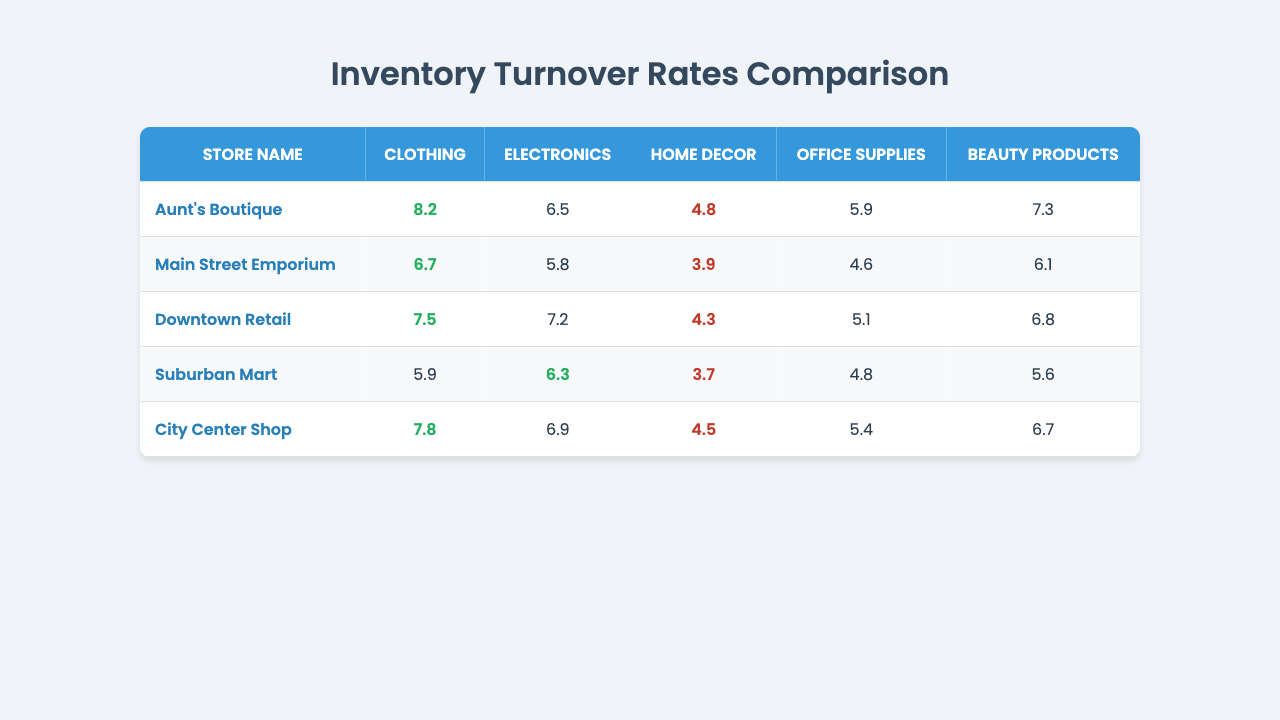What is the highest inventory turnover rate for beauty products? Looking at the beauty products column, Aunt's Boutique has the highest turnover rate at 7.3.
Answer: 7.3 Which store has the lowest turnover rate for home decor? In the home decor column, Suburban Mart has the lowest rate of 3.7.
Answer: 3.7 What is the average inventory turnover rate for clothing across all stores? The turnover rates for clothing are 8.2, 6.7, 7.5, 5.9, and 7.8. Summing these gives 35.1, and dividing by 5 results in an average of 7.02.
Answer: 7.02 Is it true that Downtown Retail has a higher turnover rate for electronics than Aunt's Boutique? Aunt's Boutique has a turnover rate of 6.5 for electronics, while Downtown Retail has 7.2. Since 7.2 is greater than 6.5, the statement is true.
Answer: True Which store has the best overall performance on inventory turnover rates, and why? Aunt's Boutique has the highest turnover rates for 4 out of 5 product categories - clothing (8.2), electronics (6.5), beauty products (7.3), and home decor (4.8). Although it does not have the overall lowest for office supplies, its higher performance in the other categories provides a strong overall result.
Answer: Aunt's Boutique What is the difference in turnover rates for office supplies between Aunt's Boutique and Main Street Emporium? Aunt's Boutique has a turnover rate for office supplies of 5.9, while Main Street Emporium has 4.6. The difference is 5.9 - 4.6 = 1.3.
Answer: 1.3 Which product category shows the least variation in turnover rates across all stores? By reviewing the turnover rates in each product category, home decor shows the least range with a maximum of 4.8 (Aunt's Boutique) and a minimum of 3.7 (Suburban Mart), giving it a variation of only 1.1.
Answer: Home Decor Who has a better turnover rate in electronics, the City Center Shop or Downtown Retail? The turnover rate for electronics at City Center Shop is 6.9, compared to Downtown Retail's 7.2. Since 7.2 is higher, Downtown Retail performs better.
Answer: Downtown Retail What would be the combined inventory turnover rate for all categories for City Center Shop? Adding all the turnover rates together: 7.8 (clothing) + 6.9 (electronics) + 4.5 (home decor) + 5.4 (office supplies) + 6.7 (beauty products) equals 31.3.
Answer: 31.3 Which store has the second highest inventory turnover for beauty products? Aunt's Boutique has the highest at 7.3, and Downtown Retail has the second highest at 6.8.
Answer: Downtown Retail Does Suburban Mart perform equally well in electronics and beauty products? Suburban Mart has an electronics turnover rate of 6.3 and a beauty products rate of 5.6. Since 6.3 is not equal to 5.6, it does not perform equally well in these categories.
Answer: No 